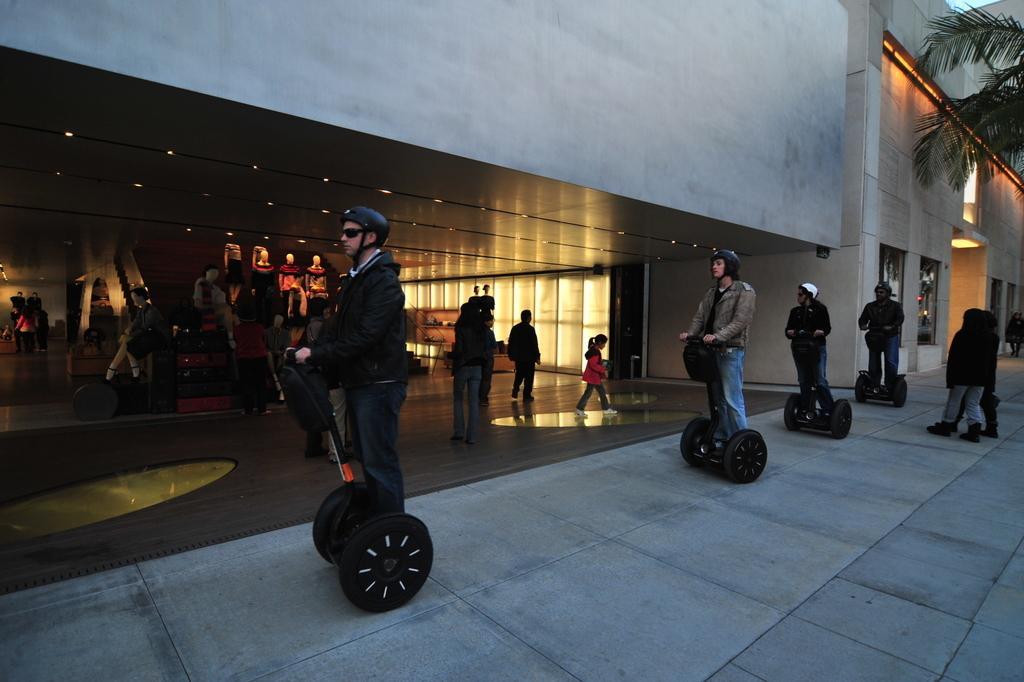In one or two sentences, can you explain what this image depicts? In this picture we can see some persons are standing on the segways and wearing helmets. In the background of the image we can see the buildings, tree, wall, stores, lights, roof, mannequins, escalator, some persons. At the bottom of the image we can see the floor. 